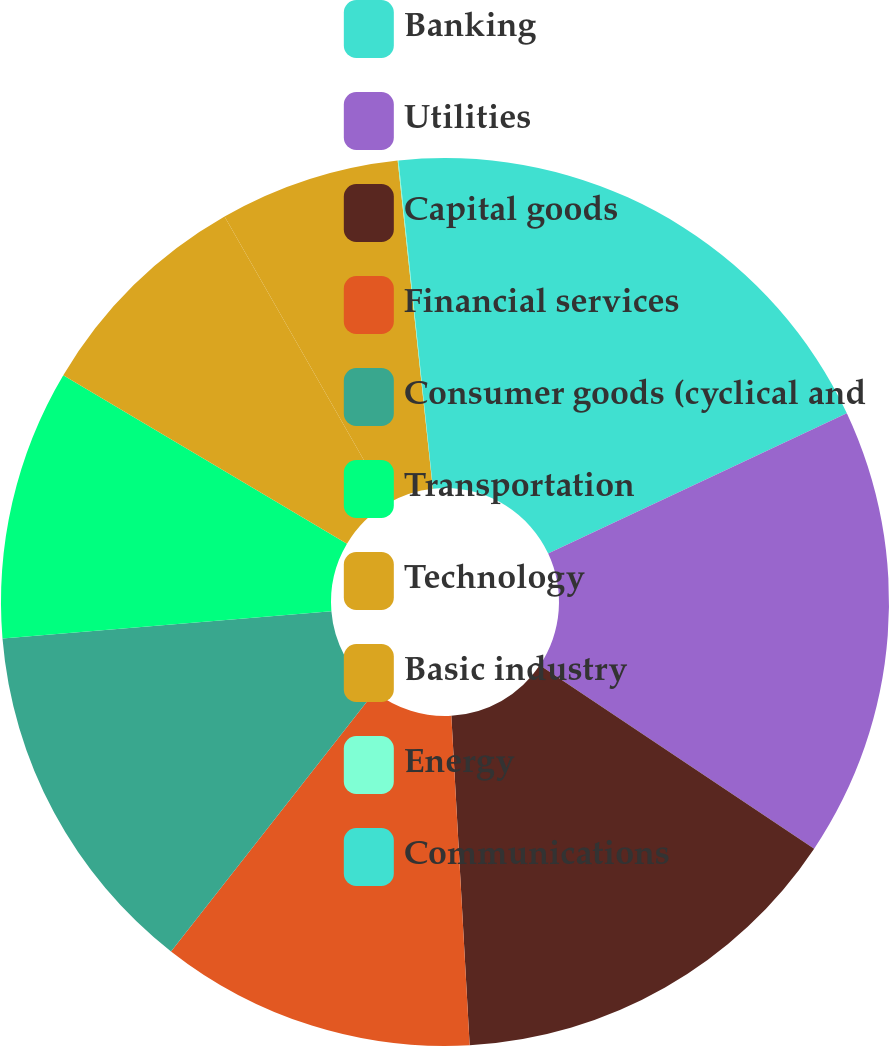Convert chart. <chart><loc_0><loc_0><loc_500><loc_500><pie_chart><fcel>Banking<fcel>Utilities<fcel>Capital goods<fcel>Financial services<fcel>Consumer goods (cyclical and<fcel>Transportation<fcel>Technology<fcel>Basic industry<fcel>Energy<fcel>Communications<nl><fcel>18.01%<fcel>16.37%<fcel>14.74%<fcel>11.47%<fcel>13.11%<fcel>9.84%<fcel>8.2%<fcel>6.57%<fcel>0.03%<fcel>1.67%<nl></chart> 